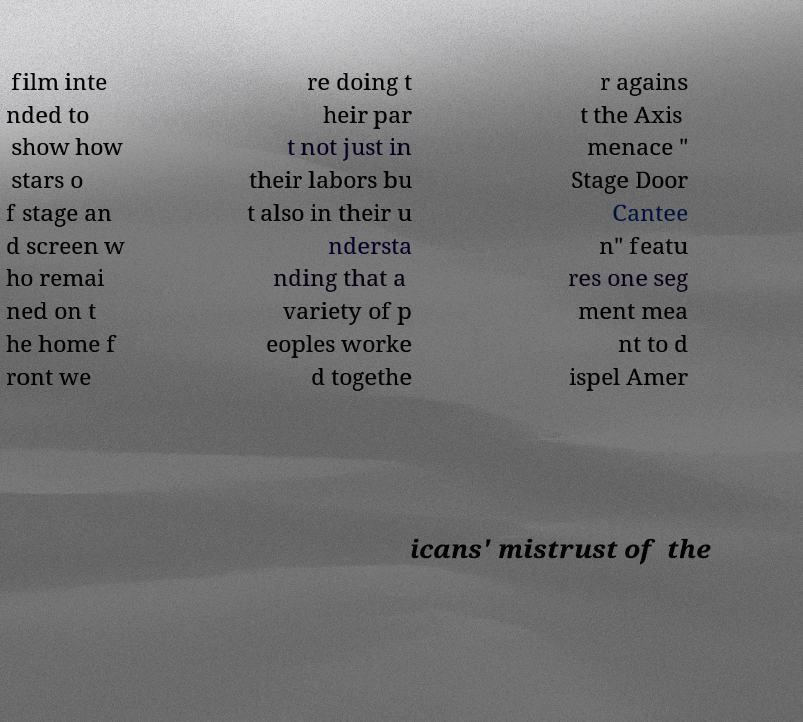Please identify and transcribe the text found in this image. film inte nded to show how stars o f stage an d screen w ho remai ned on t he home f ront we re doing t heir par t not just in their labors bu t also in their u ndersta nding that a variety of p eoples worke d togethe r agains t the Axis menace " Stage Door Cantee n" featu res one seg ment mea nt to d ispel Amer icans' mistrust of the 